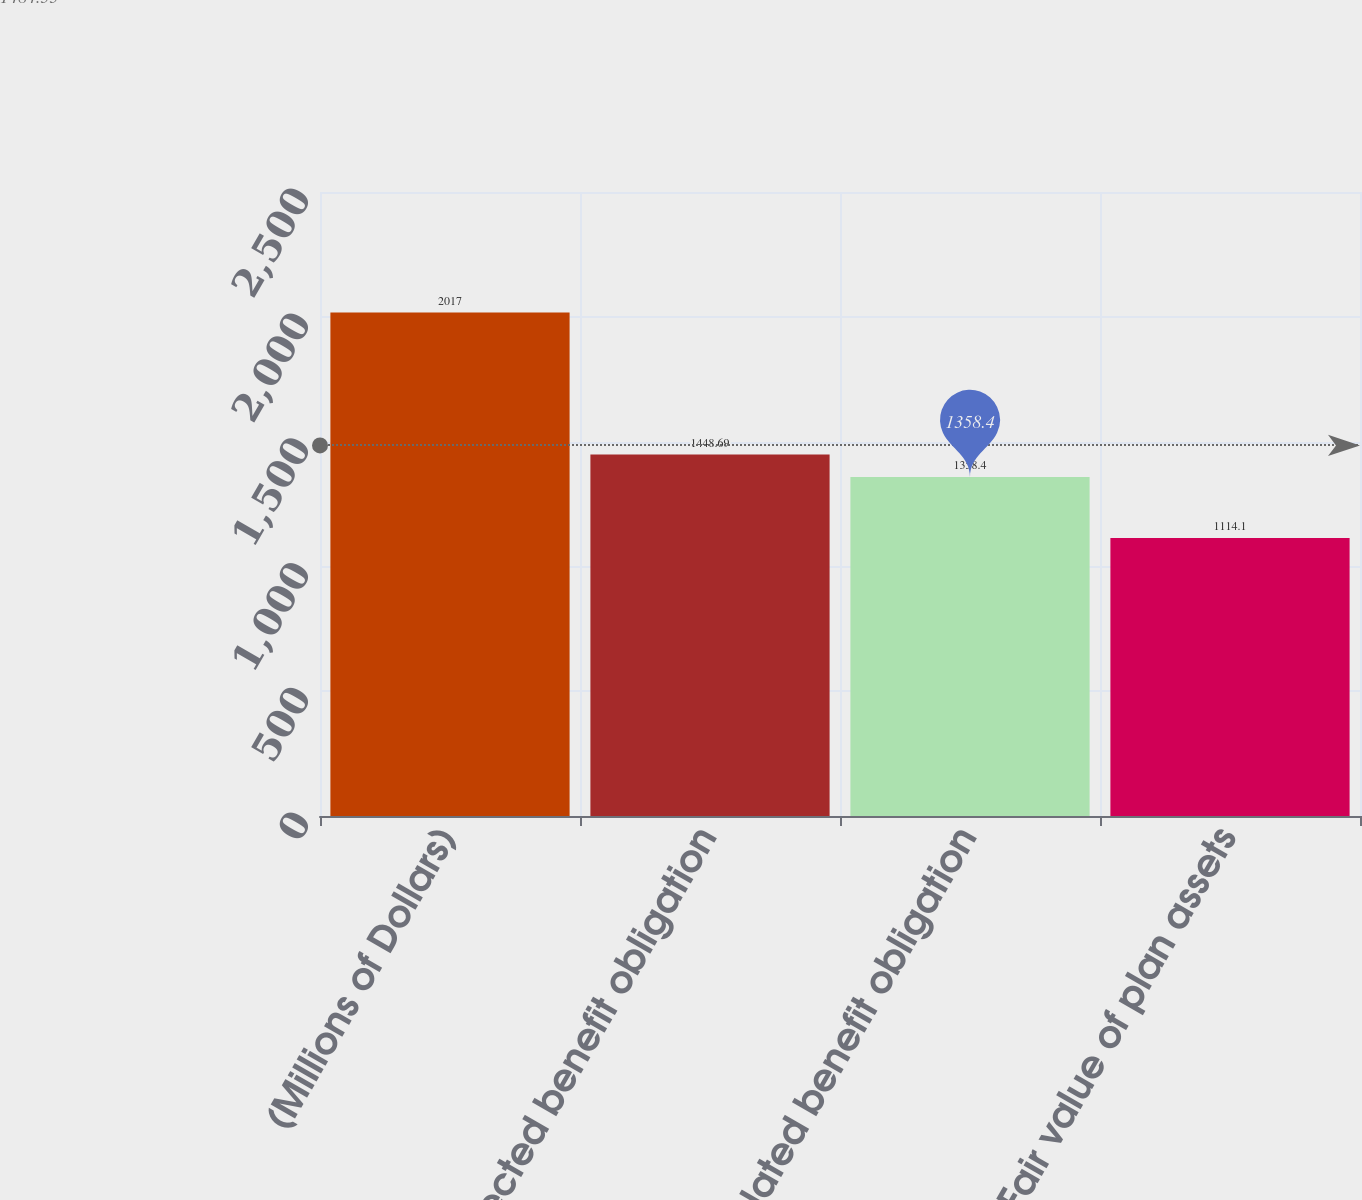<chart> <loc_0><loc_0><loc_500><loc_500><bar_chart><fcel>(Millions of Dollars)<fcel>Projected benefit obligation<fcel>Accumulated benefit obligation<fcel>Fair value of plan assets<nl><fcel>2017<fcel>1448.69<fcel>1358.4<fcel>1114.1<nl></chart> 